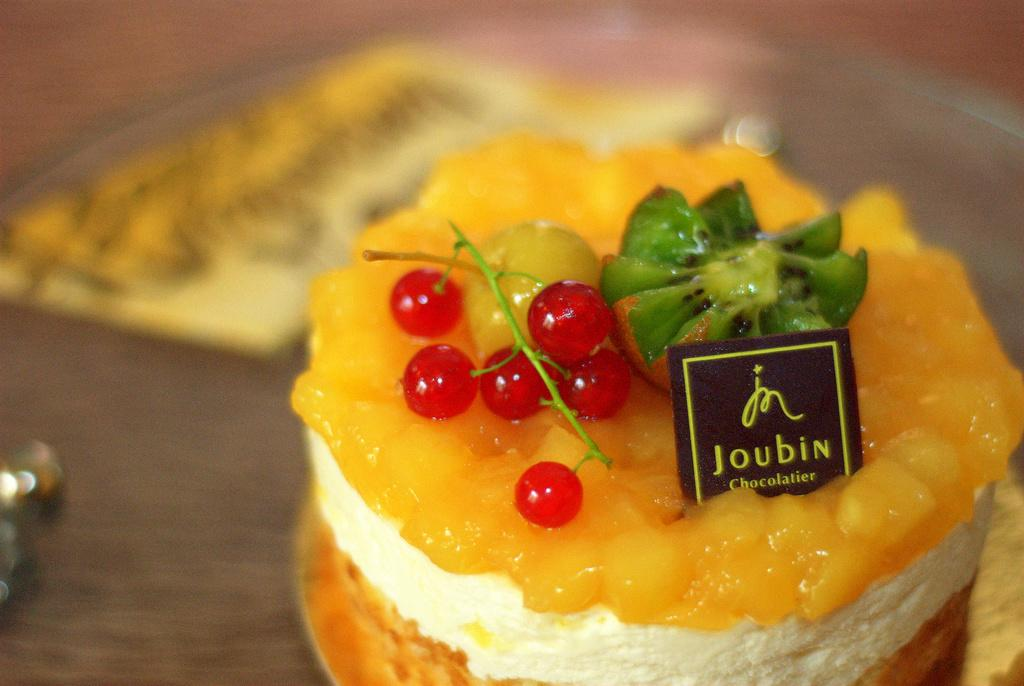What type of fruit can be seen on the cake in the image? There are cherries on the cake in the image. Are there any other types of fruit on the cake? Yes, there are other fruits on the cake. Can you describe the background of the image? The background of the image is blurry. What type of suit is the fowl wearing in the image? There is no fowl or suit present in the image. What type of cream can be seen on the cake? The provided facts do not mention any specific type of cream on the cake. 